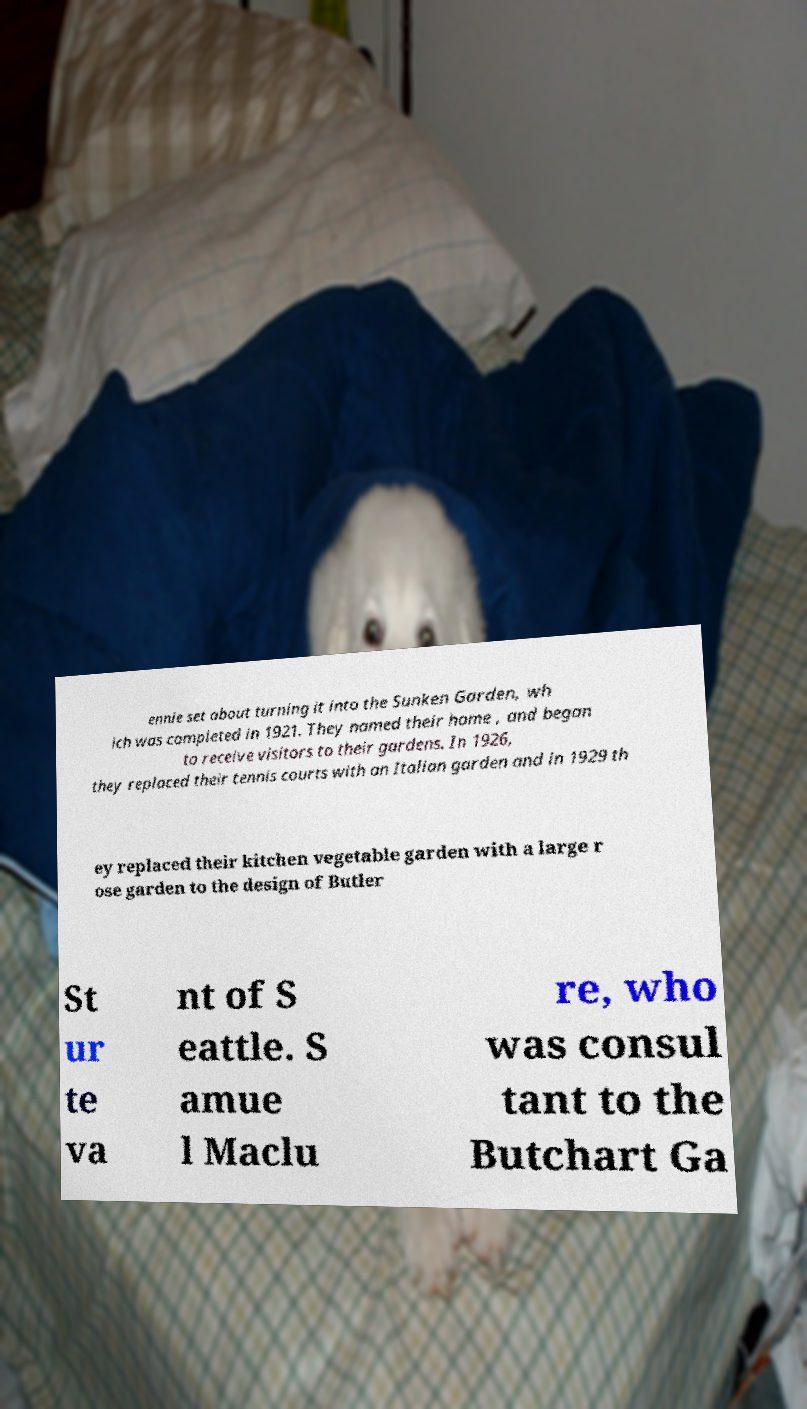What messages or text are displayed in this image? I need them in a readable, typed format. ennie set about turning it into the Sunken Garden, wh ich was completed in 1921. They named their home , and began to receive visitors to their gardens. In 1926, they replaced their tennis courts with an Italian garden and in 1929 th ey replaced their kitchen vegetable garden with a large r ose garden to the design of Butler St ur te va nt of S eattle. S amue l Maclu re, who was consul tant to the Butchart Ga 